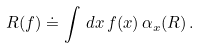Convert formula to latex. <formula><loc_0><loc_0><loc_500><loc_500>R ( f ) \doteq \int \, d x \, f ( x ) \, \alpha _ { x } ( R ) \, .</formula> 